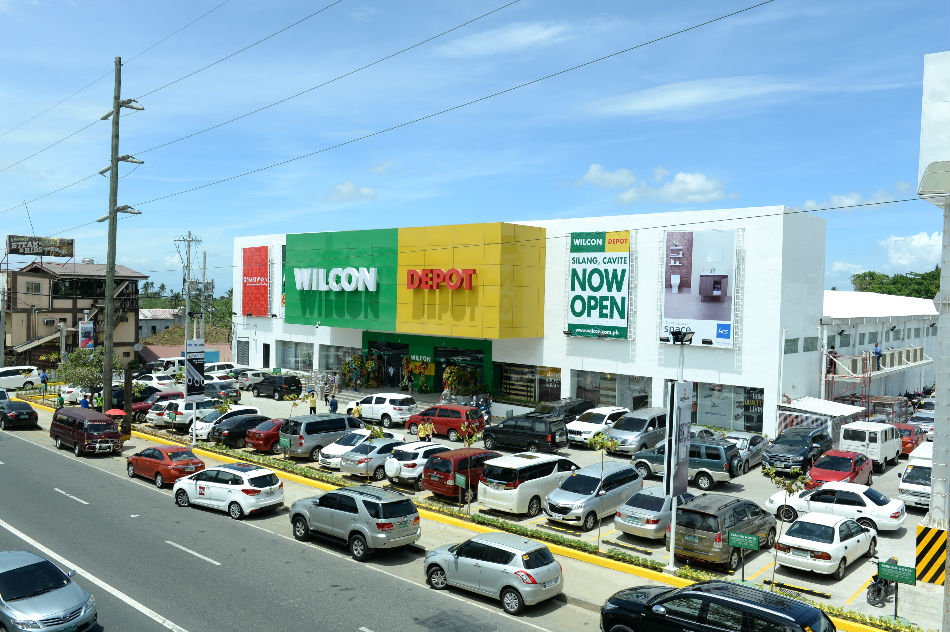What could be inferred about the local economy in the area surrounding the commercial building? The significant turnout of people and vehicles suggests that the local economy is thriving. The high customer traffic indicates that residents have disposable income to spend on retail shopping. Additionally, the presence of a newly opened store suggests that businesses see growth potential in this area, pointing to economic development and consumer confidence. 